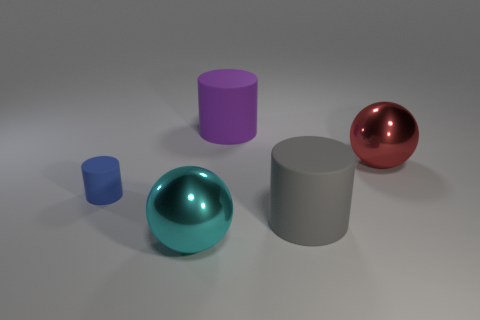Is there any other thing of the same color as the small cylinder?
Your answer should be very brief. No. There is a tiny blue thing that is left of the cyan object; what is its shape?
Offer a very short reply. Cylinder. There is a large thing that is to the left of the big gray rubber object and in front of the big red sphere; what shape is it?
Your answer should be compact. Sphere. What number of purple things are either cylinders or small cylinders?
Offer a very short reply. 1. There is a large cylinder that is right of the purple cylinder; is it the same color as the tiny cylinder?
Provide a short and direct response. No. There is a thing that is behind the ball on the right side of the purple cylinder; what size is it?
Ensure brevity in your answer.  Large. What is the material of the other sphere that is the same size as the cyan metal sphere?
Provide a succinct answer. Metal. What number of other objects are the same size as the blue rubber cylinder?
Your answer should be very brief. 0. How many cylinders are large blue rubber things or big gray matte objects?
Offer a terse response. 1. Are there any other things that are made of the same material as the large purple cylinder?
Give a very brief answer. Yes. 